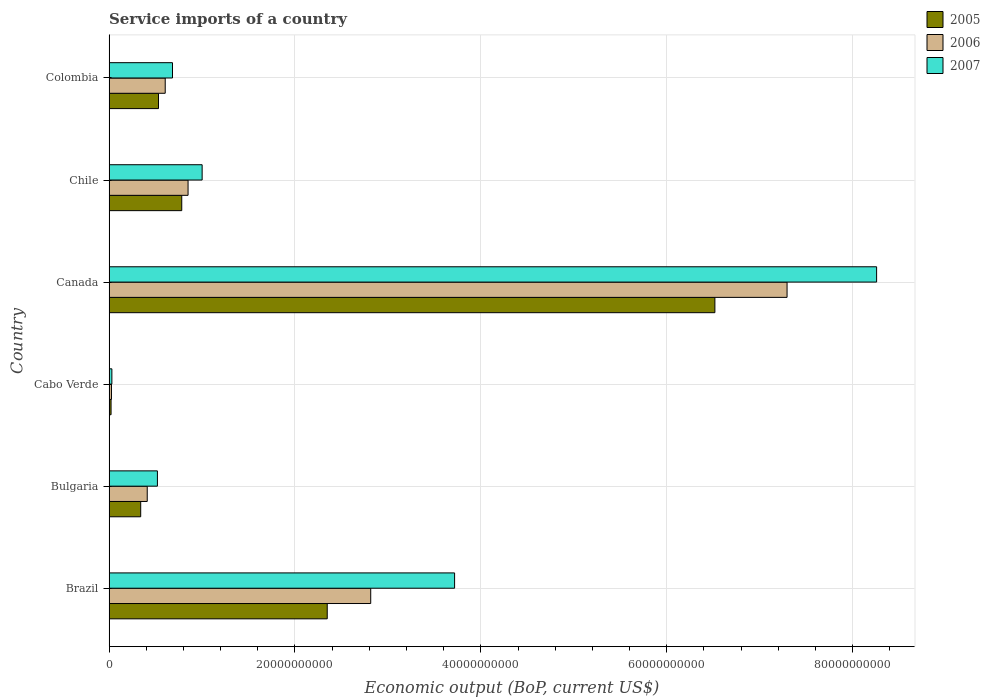How many different coloured bars are there?
Give a very brief answer. 3. How many bars are there on the 1st tick from the top?
Offer a terse response. 3. What is the label of the 1st group of bars from the top?
Provide a short and direct response. Colombia. In how many cases, is the number of bars for a given country not equal to the number of legend labels?
Ensure brevity in your answer.  0. What is the service imports in 2006 in Canada?
Keep it short and to the point. 7.29e+1. Across all countries, what is the maximum service imports in 2007?
Your response must be concise. 8.26e+1. Across all countries, what is the minimum service imports in 2007?
Your answer should be compact. 3.02e+08. In which country was the service imports in 2005 minimum?
Provide a short and direct response. Cabo Verde. What is the total service imports in 2005 in the graph?
Ensure brevity in your answer.  1.05e+11. What is the difference between the service imports in 2006 in Bulgaria and that in Colombia?
Provide a short and direct response. -1.94e+09. What is the difference between the service imports in 2005 in Canada and the service imports in 2006 in Bulgaria?
Offer a very short reply. 6.11e+1. What is the average service imports in 2005 per country?
Offer a very short reply. 1.76e+1. What is the difference between the service imports in 2007 and service imports in 2006 in Bulgaria?
Offer a terse response. 1.10e+09. In how many countries, is the service imports in 2007 greater than 16000000000 US$?
Give a very brief answer. 2. What is the ratio of the service imports in 2006 in Canada to that in Colombia?
Your response must be concise. 12.07. What is the difference between the highest and the second highest service imports in 2007?
Make the answer very short. 4.54e+1. What is the difference between the highest and the lowest service imports in 2006?
Make the answer very short. 7.27e+1. In how many countries, is the service imports in 2006 greater than the average service imports in 2006 taken over all countries?
Ensure brevity in your answer.  2. What does the 3rd bar from the top in Chile represents?
Offer a very short reply. 2005. How many countries are there in the graph?
Provide a short and direct response. 6. What is the difference between two consecutive major ticks on the X-axis?
Your answer should be compact. 2.00e+1. Are the values on the major ticks of X-axis written in scientific E-notation?
Your answer should be compact. No. Does the graph contain any zero values?
Ensure brevity in your answer.  No. Does the graph contain grids?
Provide a succinct answer. Yes. What is the title of the graph?
Your answer should be compact. Service imports of a country. Does "1973" appear as one of the legend labels in the graph?
Keep it short and to the point. No. What is the label or title of the X-axis?
Your answer should be very brief. Economic output (BoP, current US$). What is the label or title of the Y-axis?
Provide a succinct answer. Country. What is the Economic output (BoP, current US$) in 2005 in Brazil?
Give a very brief answer. 2.35e+1. What is the Economic output (BoP, current US$) of 2006 in Brazil?
Ensure brevity in your answer.  2.81e+1. What is the Economic output (BoP, current US$) in 2007 in Brazil?
Provide a succinct answer. 3.72e+1. What is the Economic output (BoP, current US$) of 2005 in Bulgaria?
Offer a terse response. 3.40e+09. What is the Economic output (BoP, current US$) in 2006 in Bulgaria?
Keep it short and to the point. 4.11e+09. What is the Economic output (BoP, current US$) of 2007 in Bulgaria?
Offer a terse response. 5.20e+09. What is the Economic output (BoP, current US$) of 2005 in Cabo Verde?
Provide a short and direct response. 2.15e+08. What is the Economic output (BoP, current US$) of 2006 in Cabo Verde?
Make the answer very short. 2.59e+08. What is the Economic output (BoP, current US$) of 2007 in Cabo Verde?
Keep it short and to the point. 3.02e+08. What is the Economic output (BoP, current US$) of 2005 in Canada?
Offer a terse response. 6.52e+1. What is the Economic output (BoP, current US$) in 2006 in Canada?
Provide a succinct answer. 7.29e+1. What is the Economic output (BoP, current US$) of 2007 in Canada?
Ensure brevity in your answer.  8.26e+1. What is the Economic output (BoP, current US$) in 2005 in Chile?
Provide a short and direct response. 7.82e+09. What is the Economic output (BoP, current US$) in 2006 in Chile?
Ensure brevity in your answer.  8.50e+09. What is the Economic output (BoP, current US$) of 2007 in Chile?
Provide a short and direct response. 1.00e+1. What is the Economic output (BoP, current US$) in 2005 in Colombia?
Keep it short and to the point. 5.32e+09. What is the Economic output (BoP, current US$) in 2006 in Colombia?
Ensure brevity in your answer.  6.04e+09. What is the Economic output (BoP, current US$) of 2007 in Colombia?
Provide a succinct answer. 6.82e+09. Across all countries, what is the maximum Economic output (BoP, current US$) in 2005?
Offer a very short reply. 6.52e+1. Across all countries, what is the maximum Economic output (BoP, current US$) of 2006?
Your response must be concise. 7.29e+1. Across all countries, what is the maximum Economic output (BoP, current US$) of 2007?
Make the answer very short. 8.26e+1. Across all countries, what is the minimum Economic output (BoP, current US$) of 2005?
Provide a succinct answer. 2.15e+08. Across all countries, what is the minimum Economic output (BoP, current US$) of 2006?
Give a very brief answer. 2.59e+08. Across all countries, what is the minimum Economic output (BoP, current US$) in 2007?
Your response must be concise. 3.02e+08. What is the total Economic output (BoP, current US$) in 2005 in the graph?
Make the answer very short. 1.05e+11. What is the total Economic output (BoP, current US$) of 2006 in the graph?
Provide a succinct answer. 1.20e+11. What is the total Economic output (BoP, current US$) in 2007 in the graph?
Provide a succinct answer. 1.42e+11. What is the difference between the Economic output (BoP, current US$) in 2005 in Brazil and that in Bulgaria?
Make the answer very short. 2.01e+1. What is the difference between the Economic output (BoP, current US$) in 2006 in Brazil and that in Bulgaria?
Keep it short and to the point. 2.40e+1. What is the difference between the Economic output (BoP, current US$) of 2007 in Brazil and that in Bulgaria?
Offer a terse response. 3.20e+1. What is the difference between the Economic output (BoP, current US$) in 2005 in Brazil and that in Cabo Verde?
Provide a succinct answer. 2.33e+1. What is the difference between the Economic output (BoP, current US$) in 2006 in Brazil and that in Cabo Verde?
Ensure brevity in your answer.  2.79e+1. What is the difference between the Economic output (BoP, current US$) of 2007 in Brazil and that in Cabo Verde?
Ensure brevity in your answer.  3.69e+1. What is the difference between the Economic output (BoP, current US$) in 2005 in Brazil and that in Canada?
Give a very brief answer. -4.17e+1. What is the difference between the Economic output (BoP, current US$) of 2006 in Brazil and that in Canada?
Give a very brief answer. -4.48e+1. What is the difference between the Economic output (BoP, current US$) of 2007 in Brazil and that in Canada?
Offer a very short reply. -4.54e+1. What is the difference between the Economic output (BoP, current US$) of 2005 in Brazil and that in Chile?
Offer a terse response. 1.57e+1. What is the difference between the Economic output (BoP, current US$) of 2006 in Brazil and that in Chile?
Provide a succinct answer. 1.97e+1. What is the difference between the Economic output (BoP, current US$) in 2007 in Brazil and that in Chile?
Ensure brevity in your answer.  2.72e+1. What is the difference between the Economic output (BoP, current US$) in 2005 in Brazil and that in Colombia?
Your answer should be very brief. 1.82e+1. What is the difference between the Economic output (BoP, current US$) in 2006 in Brazil and that in Colombia?
Provide a succinct answer. 2.21e+1. What is the difference between the Economic output (BoP, current US$) in 2007 in Brazil and that in Colombia?
Offer a very short reply. 3.03e+1. What is the difference between the Economic output (BoP, current US$) of 2005 in Bulgaria and that in Cabo Verde?
Keep it short and to the point. 3.19e+09. What is the difference between the Economic output (BoP, current US$) in 2006 in Bulgaria and that in Cabo Verde?
Your response must be concise. 3.85e+09. What is the difference between the Economic output (BoP, current US$) in 2007 in Bulgaria and that in Cabo Verde?
Your answer should be very brief. 4.90e+09. What is the difference between the Economic output (BoP, current US$) in 2005 in Bulgaria and that in Canada?
Offer a terse response. -6.18e+1. What is the difference between the Economic output (BoP, current US$) of 2006 in Bulgaria and that in Canada?
Provide a short and direct response. -6.88e+1. What is the difference between the Economic output (BoP, current US$) of 2007 in Bulgaria and that in Canada?
Provide a short and direct response. -7.74e+1. What is the difference between the Economic output (BoP, current US$) of 2005 in Bulgaria and that in Chile?
Make the answer very short. -4.41e+09. What is the difference between the Economic output (BoP, current US$) in 2006 in Bulgaria and that in Chile?
Offer a very short reply. -4.39e+09. What is the difference between the Economic output (BoP, current US$) in 2007 in Bulgaria and that in Chile?
Give a very brief answer. -4.81e+09. What is the difference between the Economic output (BoP, current US$) in 2005 in Bulgaria and that in Colombia?
Provide a succinct answer. -1.91e+09. What is the difference between the Economic output (BoP, current US$) in 2006 in Bulgaria and that in Colombia?
Provide a succinct answer. -1.94e+09. What is the difference between the Economic output (BoP, current US$) of 2007 in Bulgaria and that in Colombia?
Provide a succinct answer. -1.62e+09. What is the difference between the Economic output (BoP, current US$) in 2005 in Cabo Verde and that in Canada?
Ensure brevity in your answer.  -6.50e+1. What is the difference between the Economic output (BoP, current US$) in 2006 in Cabo Verde and that in Canada?
Your answer should be compact. -7.27e+1. What is the difference between the Economic output (BoP, current US$) of 2007 in Cabo Verde and that in Canada?
Offer a terse response. -8.23e+1. What is the difference between the Economic output (BoP, current US$) of 2005 in Cabo Verde and that in Chile?
Keep it short and to the point. -7.60e+09. What is the difference between the Economic output (BoP, current US$) of 2006 in Cabo Verde and that in Chile?
Offer a very short reply. -8.24e+09. What is the difference between the Economic output (BoP, current US$) of 2007 in Cabo Verde and that in Chile?
Offer a very short reply. -9.71e+09. What is the difference between the Economic output (BoP, current US$) in 2005 in Cabo Verde and that in Colombia?
Your answer should be very brief. -5.10e+09. What is the difference between the Economic output (BoP, current US$) in 2006 in Cabo Verde and that in Colombia?
Your answer should be compact. -5.78e+09. What is the difference between the Economic output (BoP, current US$) of 2007 in Cabo Verde and that in Colombia?
Offer a terse response. -6.52e+09. What is the difference between the Economic output (BoP, current US$) of 2005 in Canada and that in Chile?
Provide a short and direct response. 5.74e+1. What is the difference between the Economic output (BoP, current US$) in 2006 in Canada and that in Chile?
Provide a succinct answer. 6.44e+1. What is the difference between the Economic output (BoP, current US$) of 2007 in Canada and that in Chile?
Provide a short and direct response. 7.26e+1. What is the difference between the Economic output (BoP, current US$) of 2005 in Canada and that in Colombia?
Your response must be concise. 5.99e+1. What is the difference between the Economic output (BoP, current US$) of 2006 in Canada and that in Colombia?
Make the answer very short. 6.69e+1. What is the difference between the Economic output (BoP, current US$) of 2007 in Canada and that in Colombia?
Offer a very short reply. 7.58e+1. What is the difference between the Economic output (BoP, current US$) of 2005 in Chile and that in Colombia?
Your answer should be compact. 2.50e+09. What is the difference between the Economic output (BoP, current US$) in 2006 in Chile and that in Colombia?
Keep it short and to the point. 2.46e+09. What is the difference between the Economic output (BoP, current US$) of 2007 in Chile and that in Colombia?
Your answer should be very brief. 3.19e+09. What is the difference between the Economic output (BoP, current US$) of 2005 in Brazil and the Economic output (BoP, current US$) of 2006 in Bulgaria?
Your response must be concise. 1.94e+1. What is the difference between the Economic output (BoP, current US$) of 2005 in Brazil and the Economic output (BoP, current US$) of 2007 in Bulgaria?
Keep it short and to the point. 1.83e+1. What is the difference between the Economic output (BoP, current US$) of 2006 in Brazil and the Economic output (BoP, current US$) of 2007 in Bulgaria?
Make the answer very short. 2.29e+1. What is the difference between the Economic output (BoP, current US$) in 2005 in Brazil and the Economic output (BoP, current US$) in 2006 in Cabo Verde?
Your answer should be very brief. 2.32e+1. What is the difference between the Economic output (BoP, current US$) of 2005 in Brazil and the Economic output (BoP, current US$) of 2007 in Cabo Verde?
Give a very brief answer. 2.32e+1. What is the difference between the Economic output (BoP, current US$) of 2006 in Brazil and the Economic output (BoP, current US$) of 2007 in Cabo Verde?
Give a very brief answer. 2.78e+1. What is the difference between the Economic output (BoP, current US$) in 2005 in Brazil and the Economic output (BoP, current US$) in 2006 in Canada?
Your response must be concise. -4.95e+1. What is the difference between the Economic output (BoP, current US$) in 2005 in Brazil and the Economic output (BoP, current US$) in 2007 in Canada?
Provide a short and direct response. -5.91e+1. What is the difference between the Economic output (BoP, current US$) in 2006 in Brazil and the Economic output (BoP, current US$) in 2007 in Canada?
Your answer should be compact. -5.44e+1. What is the difference between the Economic output (BoP, current US$) in 2005 in Brazil and the Economic output (BoP, current US$) in 2006 in Chile?
Provide a succinct answer. 1.50e+1. What is the difference between the Economic output (BoP, current US$) in 2005 in Brazil and the Economic output (BoP, current US$) in 2007 in Chile?
Offer a very short reply. 1.35e+1. What is the difference between the Economic output (BoP, current US$) of 2006 in Brazil and the Economic output (BoP, current US$) of 2007 in Chile?
Offer a very short reply. 1.81e+1. What is the difference between the Economic output (BoP, current US$) of 2005 in Brazil and the Economic output (BoP, current US$) of 2006 in Colombia?
Your answer should be very brief. 1.74e+1. What is the difference between the Economic output (BoP, current US$) of 2005 in Brazil and the Economic output (BoP, current US$) of 2007 in Colombia?
Your response must be concise. 1.66e+1. What is the difference between the Economic output (BoP, current US$) of 2006 in Brazil and the Economic output (BoP, current US$) of 2007 in Colombia?
Provide a short and direct response. 2.13e+1. What is the difference between the Economic output (BoP, current US$) of 2005 in Bulgaria and the Economic output (BoP, current US$) of 2006 in Cabo Verde?
Provide a short and direct response. 3.14e+09. What is the difference between the Economic output (BoP, current US$) of 2005 in Bulgaria and the Economic output (BoP, current US$) of 2007 in Cabo Verde?
Keep it short and to the point. 3.10e+09. What is the difference between the Economic output (BoP, current US$) of 2006 in Bulgaria and the Economic output (BoP, current US$) of 2007 in Cabo Verde?
Make the answer very short. 3.80e+09. What is the difference between the Economic output (BoP, current US$) in 2005 in Bulgaria and the Economic output (BoP, current US$) in 2006 in Canada?
Your answer should be very brief. -6.95e+1. What is the difference between the Economic output (BoP, current US$) of 2005 in Bulgaria and the Economic output (BoP, current US$) of 2007 in Canada?
Your response must be concise. -7.92e+1. What is the difference between the Economic output (BoP, current US$) in 2006 in Bulgaria and the Economic output (BoP, current US$) in 2007 in Canada?
Your answer should be very brief. -7.85e+1. What is the difference between the Economic output (BoP, current US$) in 2005 in Bulgaria and the Economic output (BoP, current US$) in 2006 in Chile?
Offer a terse response. -5.09e+09. What is the difference between the Economic output (BoP, current US$) in 2005 in Bulgaria and the Economic output (BoP, current US$) in 2007 in Chile?
Provide a short and direct response. -6.61e+09. What is the difference between the Economic output (BoP, current US$) of 2006 in Bulgaria and the Economic output (BoP, current US$) of 2007 in Chile?
Offer a terse response. -5.91e+09. What is the difference between the Economic output (BoP, current US$) in 2005 in Bulgaria and the Economic output (BoP, current US$) in 2006 in Colombia?
Your response must be concise. -2.64e+09. What is the difference between the Economic output (BoP, current US$) of 2005 in Bulgaria and the Economic output (BoP, current US$) of 2007 in Colombia?
Keep it short and to the point. -3.42e+09. What is the difference between the Economic output (BoP, current US$) in 2006 in Bulgaria and the Economic output (BoP, current US$) in 2007 in Colombia?
Your answer should be compact. -2.72e+09. What is the difference between the Economic output (BoP, current US$) in 2005 in Cabo Verde and the Economic output (BoP, current US$) in 2006 in Canada?
Make the answer very short. -7.27e+1. What is the difference between the Economic output (BoP, current US$) in 2005 in Cabo Verde and the Economic output (BoP, current US$) in 2007 in Canada?
Your answer should be compact. -8.24e+1. What is the difference between the Economic output (BoP, current US$) in 2006 in Cabo Verde and the Economic output (BoP, current US$) in 2007 in Canada?
Provide a succinct answer. -8.23e+1. What is the difference between the Economic output (BoP, current US$) in 2005 in Cabo Verde and the Economic output (BoP, current US$) in 2006 in Chile?
Ensure brevity in your answer.  -8.28e+09. What is the difference between the Economic output (BoP, current US$) of 2005 in Cabo Verde and the Economic output (BoP, current US$) of 2007 in Chile?
Keep it short and to the point. -9.80e+09. What is the difference between the Economic output (BoP, current US$) in 2006 in Cabo Verde and the Economic output (BoP, current US$) in 2007 in Chile?
Provide a succinct answer. -9.75e+09. What is the difference between the Economic output (BoP, current US$) of 2005 in Cabo Verde and the Economic output (BoP, current US$) of 2006 in Colombia?
Offer a terse response. -5.83e+09. What is the difference between the Economic output (BoP, current US$) of 2005 in Cabo Verde and the Economic output (BoP, current US$) of 2007 in Colombia?
Provide a short and direct response. -6.61e+09. What is the difference between the Economic output (BoP, current US$) in 2006 in Cabo Verde and the Economic output (BoP, current US$) in 2007 in Colombia?
Your answer should be very brief. -6.57e+09. What is the difference between the Economic output (BoP, current US$) of 2005 in Canada and the Economic output (BoP, current US$) of 2006 in Chile?
Provide a succinct answer. 5.67e+1. What is the difference between the Economic output (BoP, current US$) in 2005 in Canada and the Economic output (BoP, current US$) in 2007 in Chile?
Give a very brief answer. 5.52e+1. What is the difference between the Economic output (BoP, current US$) in 2006 in Canada and the Economic output (BoP, current US$) in 2007 in Chile?
Keep it short and to the point. 6.29e+1. What is the difference between the Economic output (BoP, current US$) of 2005 in Canada and the Economic output (BoP, current US$) of 2006 in Colombia?
Provide a succinct answer. 5.91e+1. What is the difference between the Economic output (BoP, current US$) of 2005 in Canada and the Economic output (BoP, current US$) of 2007 in Colombia?
Provide a succinct answer. 5.84e+1. What is the difference between the Economic output (BoP, current US$) in 2006 in Canada and the Economic output (BoP, current US$) in 2007 in Colombia?
Provide a succinct answer. 6.61e+1. What is the difference between the Economic output (BoP, current US$) in 2005 in Chile and the Economic output (BoP, current US$) in 2006 in Colombia?
Offer a very short reply. 1.78e+09. What is the difference between the Economic output (BoP, current US$) of 2005 in Chile and the Economic output (BoP, current US$) of 2007 in Colombia?
Your answer should be very brief. 9.94e+08. What is the difference between the Economic output (BoP, current US$) in 2006 in Chile and the Economic output (BoP, current US$) in 2007 in Colombia?
Your answer should be very brief. 1.67e+09. What is the average Economic output (BoP, current US$) of 2005 per country?
Offer a terse response. 1.76e+1. What is the average Economic output (BoP, current US$) of 2006 per country?
Your answer should be very brief. 2.00e+1. What is the average Economic output (BoP, current US$) of 2007 per country?
Provide a short and direct response. 2.37e+1. What is the difference between the Economic output (BoP, current US$) of 2005 and Economic output (BoP, current US$) of 2006 in Brazil?
Your answer should be very brief. -4.68e+09. What is the difference between the Economic output (BoP, current US$) of 2005 and Economic output (BoP, current US$) of 2007 in Brazil?
Your answer should be compact. -1.37e+1. What is the difference between the Economic output (BoP, current US$) in 2006 and Economic output (BoP, current US$) in 2007 in Brazil?
Provide a short and direct response. -9.02e+09. What is the difference between the Economic output (BoP, current US$) in 2005 and Economic output (BoP, current US$) in 2006 in Bulgaria?
Provide a short and direct response. -7.02e+08. What is the difference between the Economic output (BoP, current US$) in 2005 and Economic output (BoP, current US$) in 2007 in Bulgaria?
Your answer should be very brief. -1.80e+09. What is the difference between the Economic output (BoP, current US$) of 2006 and Economic output (BoP, current US$) of 2007 in Bulgaria?
Keep it short and to the point. -1.10e+09. What is the difference between the Economic output (BoP, current US$) of 2005 and Economic output (BoP, current US$) of 2006 in Cabo Verde?
Provide a succinct answer. -4.44e+07. What is the difference between the Economic output (BoP, current US$) in 2005 and Economic output (BoP, current US$) in 2007 in Cabo Verde?
Offer a terse response. -8.69e+07. What is the difference between the Economic output (BoP, current US$) in 2006 and Economic output (BoP, current US$) in 2007 in Cabo Verde?
Your answer should be compact. -4.25e+07. What is the difference between the Economic output (BoP, current US$) of 2005 and Economic output (BoP, current US$) of 2006 in Canada?
Provide a short and direct response. -7.77e+09. What is the difference between the Economic output (BoP, current US$) of 2005 and Economic output (BoP, current US$) of 2007 in Canada?
Give a very brief answer. -1.74e+1. What is the difference between the Economic output (BoP, current US$) in 2006 and Economic output (BoP, current US$) in 2007 in Canada?
Make the answer very short. -9.63e+09. What is the difference between the Economic output (BoP, current US$) of 2005 and Economic output (BoP, current US$) of 2006 in Chile?
Give a very brief answer. -6.80e+08. What is the difference between the Economic output (BoP, current US$) of 2005 and Economic output (BoP, current US$) of 2007 in Chile?
Give a very brief answer. -2.19e+09. What is the difference between the Economic output (BoP, current US$) in 2006 and Economic output (BoP, current US$) in 2007 in Chile?
Provide a succinct answer. -1.51e+09. What is the difference between the Economic output (BoP, current US$) in 2005 and Economic output (BoP, current US$) in 2006 in Colombia?
Keep it short and to the point. -7.23e+08. What is the difference between the Economic output (BoP, current US$) of 2005 and Economic output (BoP, current US$) of 2007 in Colombia?
Provide a succinct answer. -1.51e+09. What is the difference between the Economic output (BoP, current US$) in 2006 and Economic output (BoP, current US$) in 2007 in Colombia?
Make the answer very short. -7.84e+08. What is the ratio of the Economic output (BoP, current US$) in 2005 in Brazil to that in Bulgaria?
Give a very brief answer. 6.9. What is the ratio of the Economic output (BoP, current US$) in 2006 in Brazil to that in Bulgaria?
Make the answer very short. 6.86. What is the ratio of the Economic output (BoP, current US$) of 2007 in Brazil to that in Bulgaria?
Your answer should be compact. 7.15. What is the ratio of the Economic output (BoP, current US$) in 2005 in Brazil to that in Cabo Verde?
Your answer should be very brief. 109.36. What is the ratio of the Economic output (BoP, current US$) of 2006 in Brazil to that in Cabo Verde?
Your answer should be compact. 108.66. What is the ratio of the Economic output (BoP, current US$) of 2007 in Brazil to that in Cabo Verde?
Provide a short and direct response. 123.27. What is the ratio of the Economic output (BoP, current US$) of 2005 in Brazil to that in Canada?
Your answer should be compact. 0.36. What is the ratio of the Economic output (BoP, current US$) in 2006 in Brazil to that in Canada?
Your answer should be compact. 0.39. What is the ratio of the Economic output (BoP, current US$) in 2007 in Brazil to that in Canada?
Your answer should be compact. 0.45. What is the ratio of the Economic output (BoP, current US$) in 2005 in Brazil to that in Chile?
Your answer should be compact. 3. What is the ratio of the Economic output (BoP, current US$) of 2006 in Brazil to that in Chile?
Offer a very short reply. 3.31. What is the ratio of the Economic output (BoP, current US$) of 2007 in Brazil to that in Chile?
Keep it short and to the point. 3.71. What is the ratio of the Economic output (BoP, current US$) in 2005 in Brazil to that in Colombia?
Offer a terse response. 4.41. What is the ratio of the Economic output (BoP, current US$) of 2006 in Brazil to that in Colombia?
Your response must be concise. 4.66. What is the ratio of the Economic output (BoP, current US$) in 2007 in Brazil to that in Colombia?
Give a very brief answer. 5.45. What is the ratio of the Economic output (BoP, current US$) of 2005 in Bulgaria to that in Cabo Verde?
Ensure brevity in your answer.  15.86. What is the ratio of the Economic output (BoP, current US$) of 2006 in Bulgaria to that in Cabo Verde?
Give a very brief answer. 15.85. What is the ratio of the Economic output (BoP, current US$) of 2007 in Bulgaria to that in Cabo Verde?
Your answer should be compact. 17.25. What is the ratio of the Economic output (BoP, current US$) of 2005 in Bulgaria to that in Canada?
Make the answer very short. 0.05. What is the ratio of the Economic output (BoP, current US$) in 2006 in Bulgaria to that in Canada?
Your answer should be compact. 0.06. What is the ratio of the Economic output (BoP, current US$) in 2007 in Bulgaria to that in Canada?
Your answer should be compact. 0.06. What is the ratio of the Economic output (BoP, current US$) of 2005 in Bulgaria to that in Chile?
Your answer should be very brief. 0.44. What is the ratio of the Economic output (BoP, current US$) of 2006 in Bulgaria to that in Chile?
Give a very brief answer. 0.48. What is the ratio of the Economic output (BoP, current US$) of 2007 in Bulgaria to that in Chile?
Make the answer very short. 0.52. What is the ratio of the Economic output (BoP, current US$) in 2005 in Bulgaria to that in Colombia?
Ensure brevity in your answer.  0.64. What is the ratio of the Economic output (BoP, current US$) in 2006 in Bulgaria to that in Colombia?
Make the answer very short. 0.68. What is the ratio of the Economic output (BoP, current US$) of 2007 in Bulgaria to that in Colombia?
Your answer should be very brief. 0.76. What is the ratio of the Economic output (BoP, current US$) in 2005 in Cabo Verde to that in Canada?
Offer a very short reply. 0. What is the ratio of the Economic output (BoP, current US$) in 2006 in Cabo Verde to that in Canada?
Provide a succinct answer. 0. What is the ratio of the Economic output (BoP, current US$) in 2007 in Cabo Verde to that in Canada?
Give a very brief answer. 0. What is the ratio of the Economic output (BoP, current US$) of 2005 in Cabo Verde to that in Chile?
Ensure brevity in your answer.  0.03. What is the ratio of the Economic output (BoP, current US$) in 2006 in Cabo Verde to that in Chile?
Your response must be concise. 0.03. What is the ratio of the Economic output (BoP, current US$) of 2007 in Cabo Verde to that in Chile?
Offer a terse response. 0.03. What is the ratio of the Economic output (BoP, current US$) in 2005 in Cabo Verde to that in Colombia?
Offer a very short reply. 0.04. What is the ratio of the Economic output (BoP, current US$) of 2006 in Cabo Verde to that in Colombia?
Your response must be concise. 0.04. What is the ratio of the Economic output (BoP, current US$) in 2007 in Cabo Verde to that in Colombia?
Provide a succinct answer. 0.04. What is the ratio of the Economic output (BoP, current US$) in 2005 in Canada to that in Chile?
Ensure brevity in your answer.  8.34. What is the ratio of the Economic output (BoP, current US$) of 2006 in Canada to that in Chile?
Provide a succinct answer. 8.58. What is the ratio of the Economic output (BoP, current US$) in 2007 in Canada to that in Chile?
Give a very brief answer. 8.25. What is the ratio of the Economic output (BoP, current US$) of 2005 in Canada to that in Colombia?
Offer a very short reply. 12.25. What is the ratio of the Economic output (BoP, current US$) in 2006 in Canada to that in Colombia?
Give a very brief answer. 12.07. What is the ratio of the Economic output (BoP, current US$) in 2007 in Canada to that in Colombia?
Offer a terse response. 12.1. What is the ratio of the Economic output (BoP, current US$) in 2005 in Chile to that in Colombia?
Offer a terse response. 1.47. What is the ratio of the Economic output (BoP, current US$) in 2006 in Chile to that in Colombia?
Keep it short and to the point. 1.41. What is the ratio of the Economic output (BoP, current US$) of 2007 in Chile to that in Colombia?
Give a very brief answer. 1.47. What is the difference between the highest and the second highest Economic output (BoP, current US$) of 2005?
Ensure brevity in your answer.  4.17e+1. What is the difference between the highest and the second highest Economic output (BoP, current US$) in 2006?
Offer a terse response. 4.48e+1. What is the difference between the highest and the second highest Economic output (BoP, current US$) in 2007?
Provide a succinct answer. 4.54e+1. What is the difference between the highest and the lowest Economic output (BoP, current US$) of 2005?
Give a very brief answer. 6.50e+1. What is the difference between the highest and the lowest Economic output (BoP, current US$) in 2006?
Keep it short and to the point. 7.27e+1. What is the difference between the highest and the lowest Economic output (BoP, current US$) of 2007?
Offer a very short reply. 8.23e+1. 